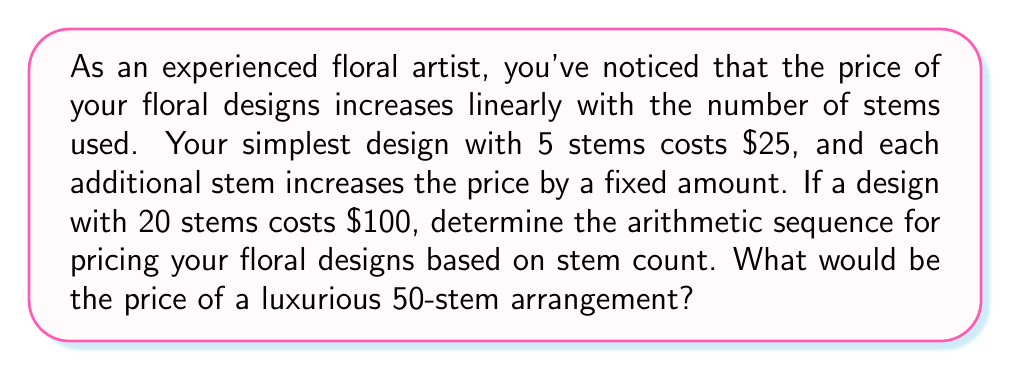Can you solve this math problem? Let's approach this step-by-step:

1) We have an arithmetic sequence where the number of stems is the term number (n) and the price is the term value (a_n).

2) We know two points in this sequence:
   - When n = 5, a_5 = $25
   - When n = 20, a_20 = $100

3) In an arithmetic sequence, the common difference (d) is constant. Let's find d:
   
   $$ d = \frac{a_{20} - a_5}{20 - 5} = \frac{100 - 25}{15} = 5 $$

4) So, the price increases by $5 for each additional stem.

5) Now we can find the first term (a_1) using the formula:
   $$ a_n = a_1 + (n-1)d $$
   
   For n = 5: $25 = a_1 + (5-1)5$
   $25 = a_1 + 20$
   $a_1 = 5$

6) Therefore, our arithmetic sequence is:
   $$ a_n = 5 + (n-1)5 = 5n $$

7) To find the price of a 50-stem arrangement, we simply plug in n = 50:
   $$ a_{50} = 5(50) = 250 $$
Answer: $a_n = 5n$; $250 